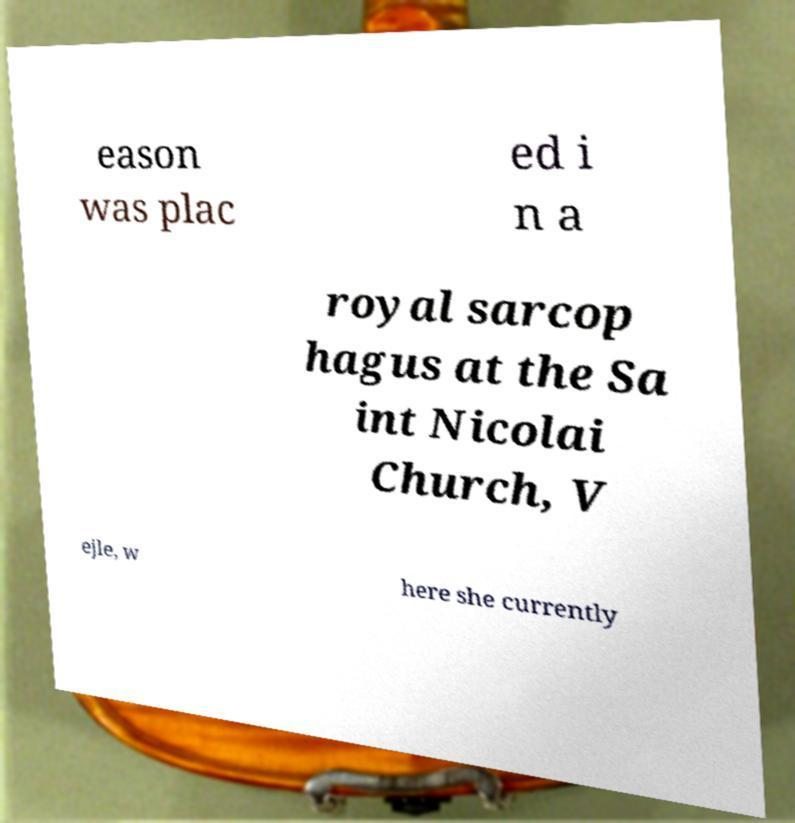Could you extract and type out the text from this image? eason was plac ed i n a royal sarcop hagus at the Sa int Nicolai Church, V ejle, w here she currently 